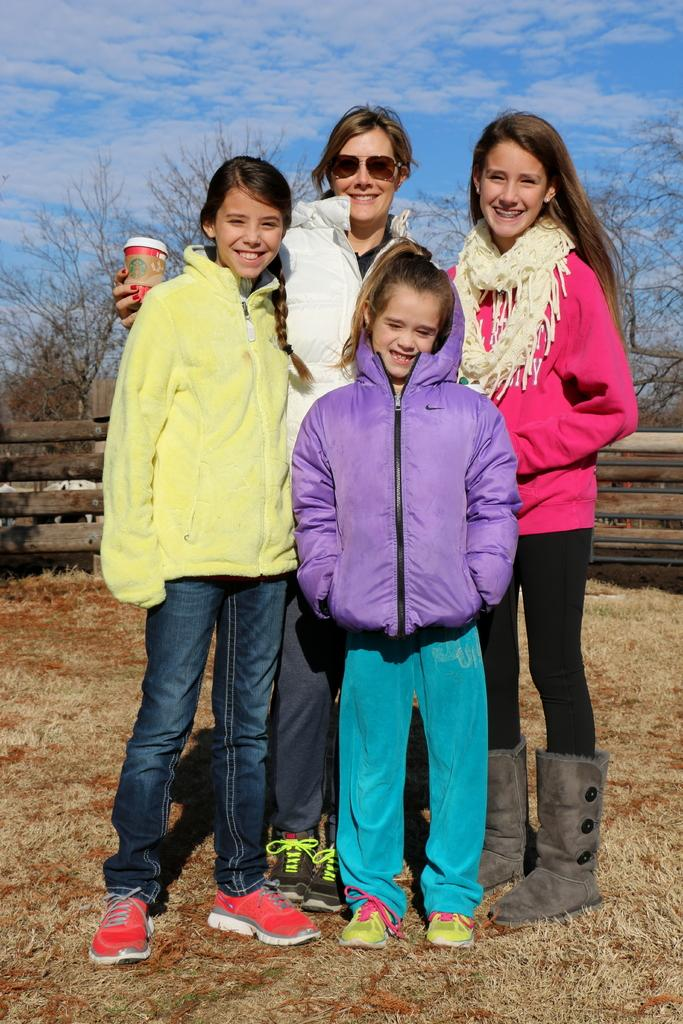What are the people in the image doing? The persons standing on the ground are likely engaged in some activity or conversation. What is the woman holding in her hand? The woman is holding a cup in her hand. What can be seen in the background of the image? There is a fence and trees in the background of the image, as well as clouds visible in the sky. What type of engine can be seen powering the woman's cup in the image? There is no engine present in the image, and the woman's cup is not powered by any engine. 